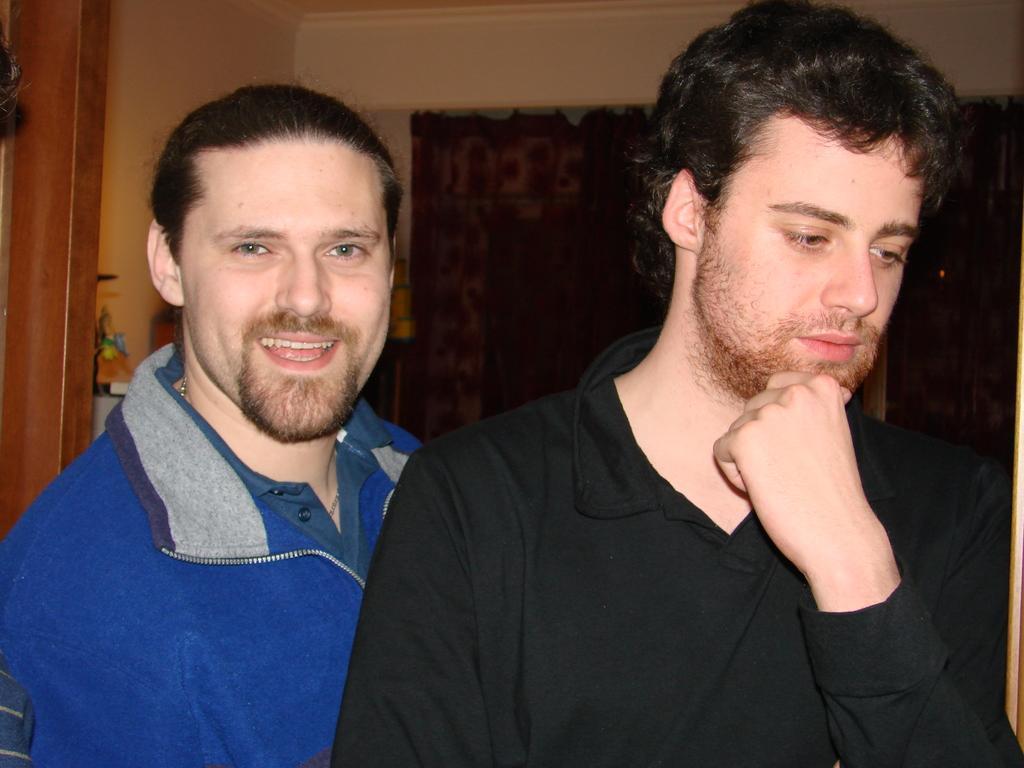How would you summarize this image in a sentence or two? In this image I can see two people. In the background, I can see the wall. 